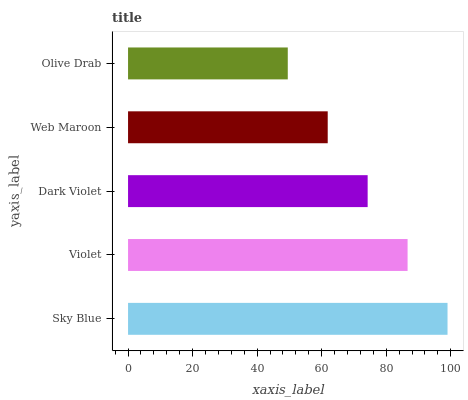Is Olive Drab the minimum?
Answer yes or no. Yes. Is Sky Blue the maximum?
Answer yes or no. Yes. Is Violet the minimum?
Answer yes or no. No. Is Violet the maximum?
Answer yes or no. No. Is Sky Blue greater than Violet?
Answer yes or no. Yes. Is Violet less than Sky Blue?
Answer yes or no. Yes. Is Violet greater than Sky Blue?
Answer yes or no. No. Is Sky Blue less than Violet?
Answer yes or no. No. Is Dark Violet the high median?
Answer yes or no. Yes. Is Dark Violet the low median?
Answer yes or no. Yes. Is Web Maroon the high median?
Answer yes or no. No. Is Violet the low median?
Answer yes or no. No. 